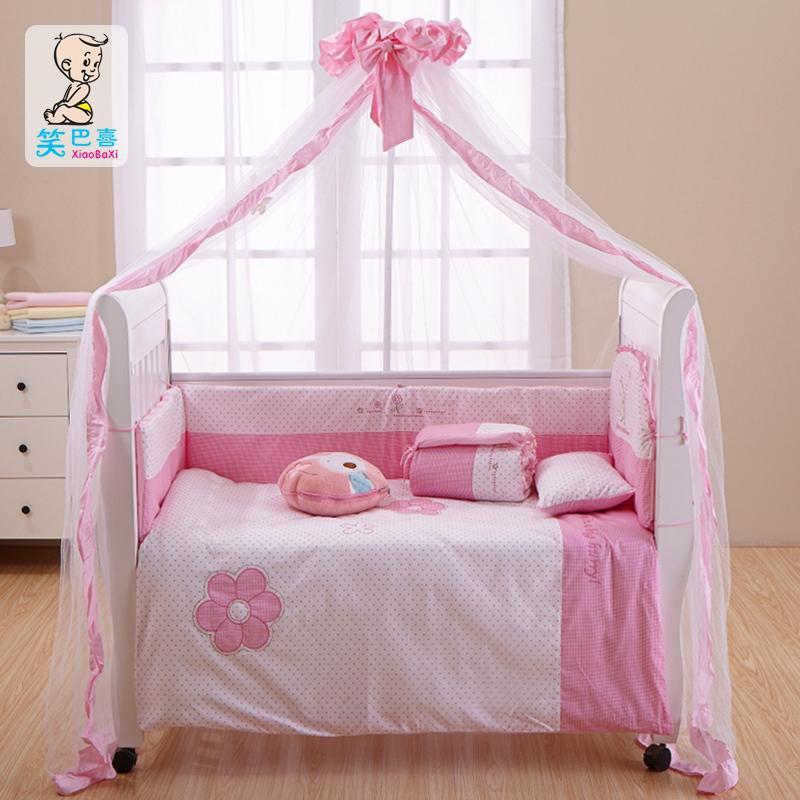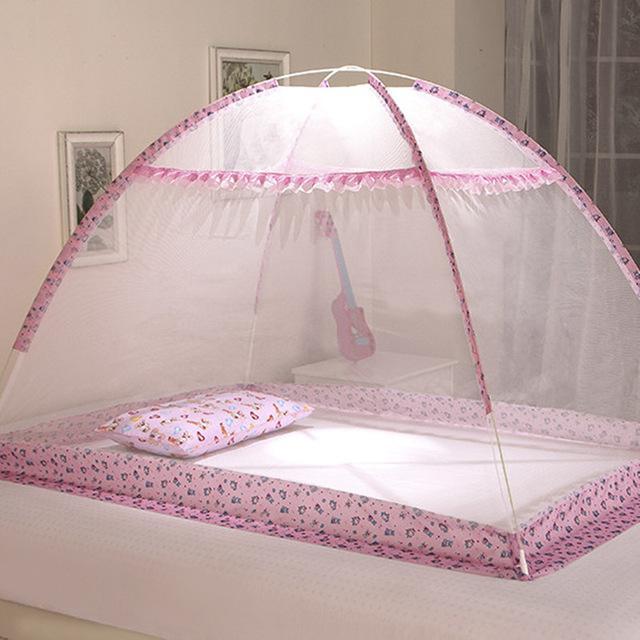The first image is the image on the left, the second image is the image on the right. For the images displayed, is the sentence "There are two pink canopies ." factually correct? Answer yes or no. Yes. The first image is the image on the left, the second image is the image on the right. Examine the images to the left and right. Is the description "There is exactly one baby crib." accurate? Answer yes or no. Yes. 